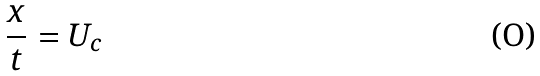<formula> <loc_0><loc_0><loc_500><loc_500>\frac { x } { t } = U _ { c }</formula> 